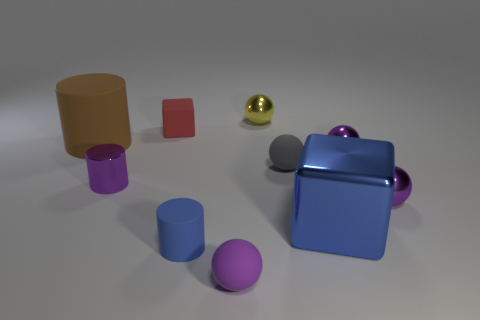Subtract all purple balls. How many were subtracted if there are1purple balls left? 2 Subtract all yellow cubes. How many purple spheres are left? 3 Subtract all gray spheres. How many spheres are left? 4 Subtract all gray matte spheres. How many spheres are left? 4 Subtract all blue cubes. Subtract all gray balls. How many cubes are left? 1 Subtract all cylinders. How many objects are left? 7 Add 5 purple matte objects. How many purple matte objects exist? 6 Subtract 0 brown spheres. How many objects are left? 10 Subtract all tiny purple cylinders. Subtract all rubber cylinders. How many objects are left? 7 Add 3 big brown rubber cylinders. How many big brown rubber cylinders are left? 4 